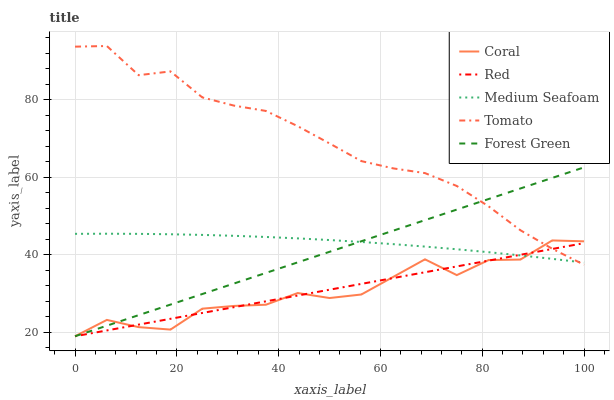Does Medium Seafoam have the minimum area under the curve?
Answer yes or no. No. Does Medium Seafoam have the maximum area under the curve?
Answer yes or no. No. Is Medium Seafoam the smoothest?
Answer yes or no. No. Is Medium Seafoam the roughest?
Answer yes or no. No. Does Medium Seafoam have the lowest value?
Answer yes or no. No. Does Coral have the highest value?
Answer yes or no. No. 